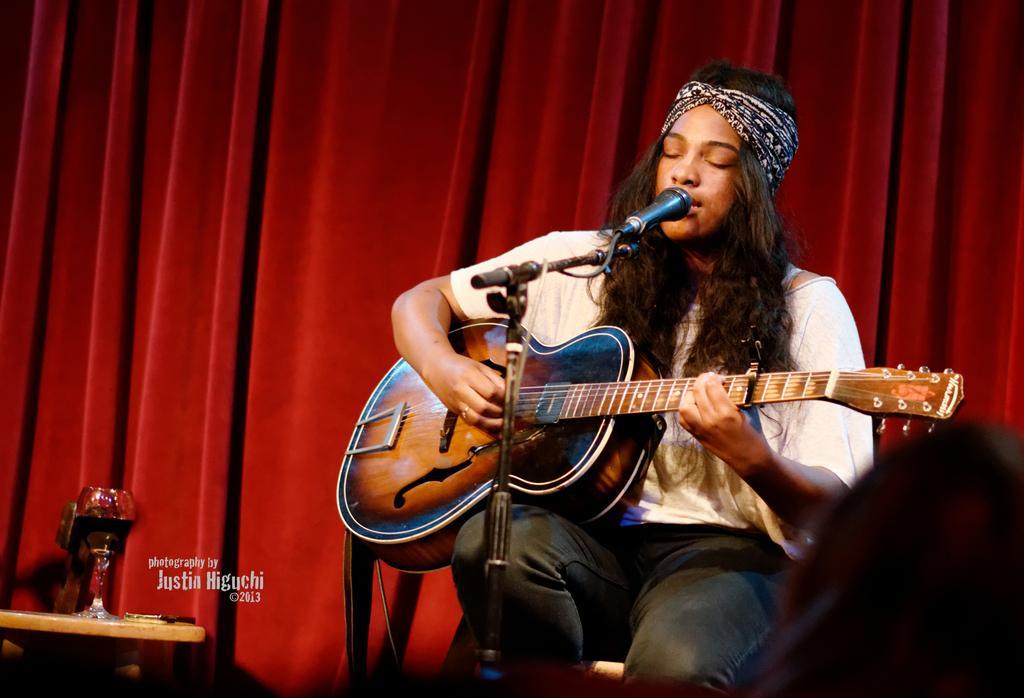In one or two sentences, can you explain what this image depicts? In this image, there is a person wearing clothes and sitting in front of the mic. This person is playing a guitar. There is a red background behind this person. There is a table in the bottom left of the image contains a glass. 